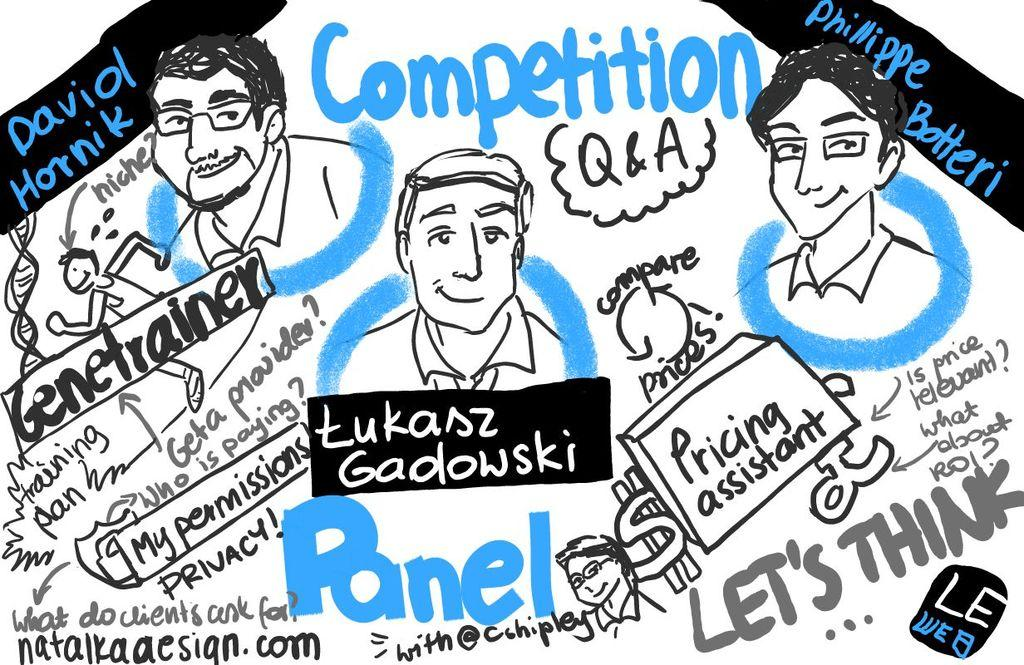What type of image is depicted in the poster? The image is a poster. What kind of characters can be seen on the poster? There are cartoon images of people on the poster. Is there any text present on the poster? Yes, there is text written on the poster. What type of sack is being smashed by the cartoon character on the poster? There is no sack or smashing depicted on the poster; it features cartoon images of people and text. 